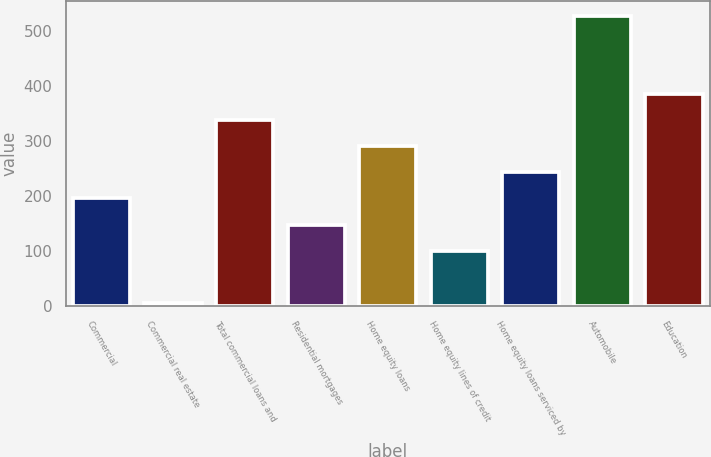<chart> <loc_0><loc_0><loc_500><loc_500><bar_chart><fcel>Commercial<fcel>Commercial real estate<fcel>Total commercial loans and<fcel>Residential mortgages<fcel>Home equity loans<fcel>Home equity lines of credit<fcel>Home equity loans serviced by<fcel>Automobile<fcel>Education<nl><fcel>195.6<fcel>6<fcel>337.8<fcel>148.2<fcel>290.4<fcel>100.8<fcel>243<fcel>527.4<fcel>385.2<nl></chart> 